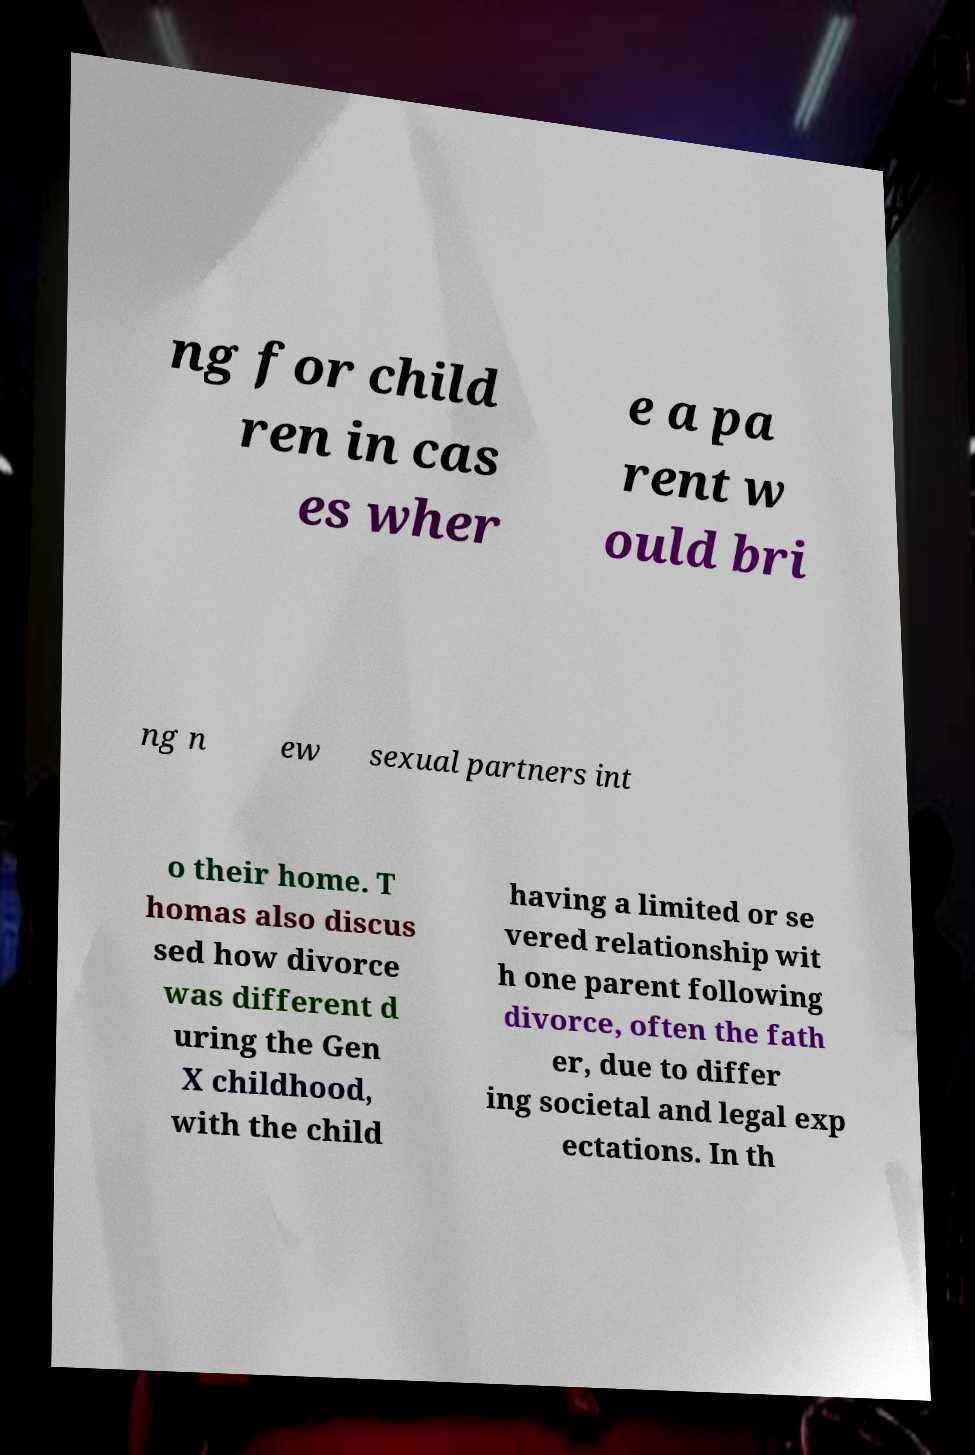There's text embedded in this image that I need extracted. Can you transcribe it verbatim? ng for child ren in cas es wher e a pa rent w ould bri ng n ew sexual partners int o their home. T homas also discus sed how divorce was different d uring the Gen X childhood, with the child having a limited or se vered relationship wit h one parent following divorce, often the fath er, due to differ ing societal and legal exp ectations. In th 